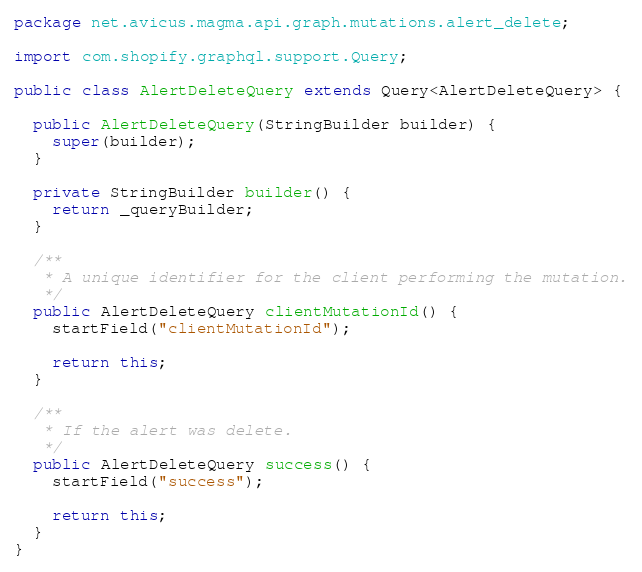Convert code to text. <code><loc_0><loc_0><loc_500><loc_500><_Java_>package net.avicus.magma.api.graph.mutations.alert_delete;

import com.shopify.graphql.support.Query;

public class AlertDeleteQuery extends Query<AlertDeleteQuery> {

  public AlertDeleteQuery(StringBuilder builder) {
    super(builder);
  }

  private StringBuilder builder() {
    return _queryBuilder;
  }

  /**
   * A unique identifier for the client performing the mutation.
   */
  public AlertDeleteQuery clientMutationId() {
    startField("clientMutationId");

    return this;
  }

  /**
   * If the alert was delete.
   */
  public AlertDeleteQuery success() {
    startField("success");

    return this;
  }
}
</code> 